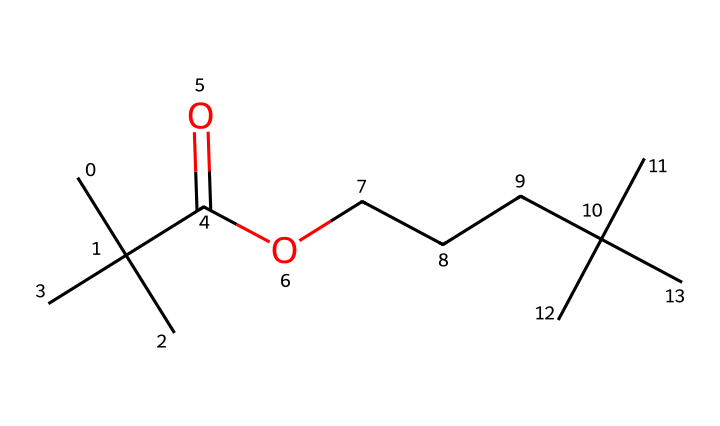What type of functional group is present in this chemical? The chemical contains a carboxylic acid functional group as indicated by the presence of the -C(=O)O- structure, which consists of a carbonyl (C=O) and a hydroxyl (-OH) group.
Answer: carboxylic acid How many carbon atoms does this molecule contain? Counting the carbon atoms in the SMILES structure shows that there are 10 carbon atoms present throughout the molecule.
Answer: 10 What is the general purpose of this chemical in bandages? This chemical acts primarily as an adhesive due to its ability to bond surfaces together, which is crucial for holding the bandage in place on the skin.
Answer: adhesive How many oxygen atoms are present in this chemical? By analyzing the SMILES representation, we find that there are 2 oxygen atoms in the molecule, one from the carboxylic acid group and another from the hydroxyl group.
Answer: 2 Is this chemical likely to be hydrophobic or hydrophilic? The presence of the carboxylic acid functional group generally increases the hydrophilicity, meaning this chemical tends to interact well with water.
Answer: hydrophilic Does this molecule contain any double bonds? Yes, the chemical has a double bond in the carboxylic acid functional group (C=O).
Answer: yes 